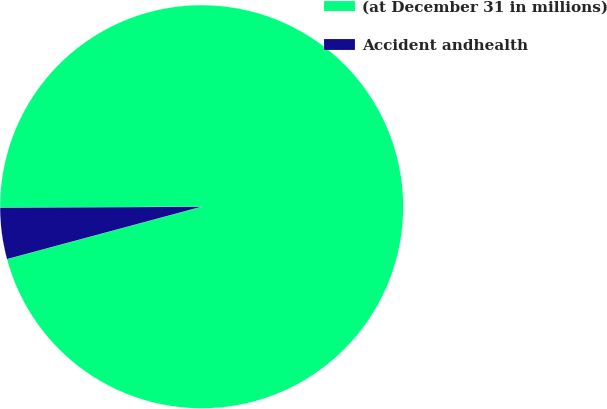<chart> <loc_0><loc_0><loc_500><loc_500><pie_chart><fcel>(at December 31 in millions)<fcel>Accident andhealth<nl><fcel>95.89%<fcel>4.11%<nl></chart> 